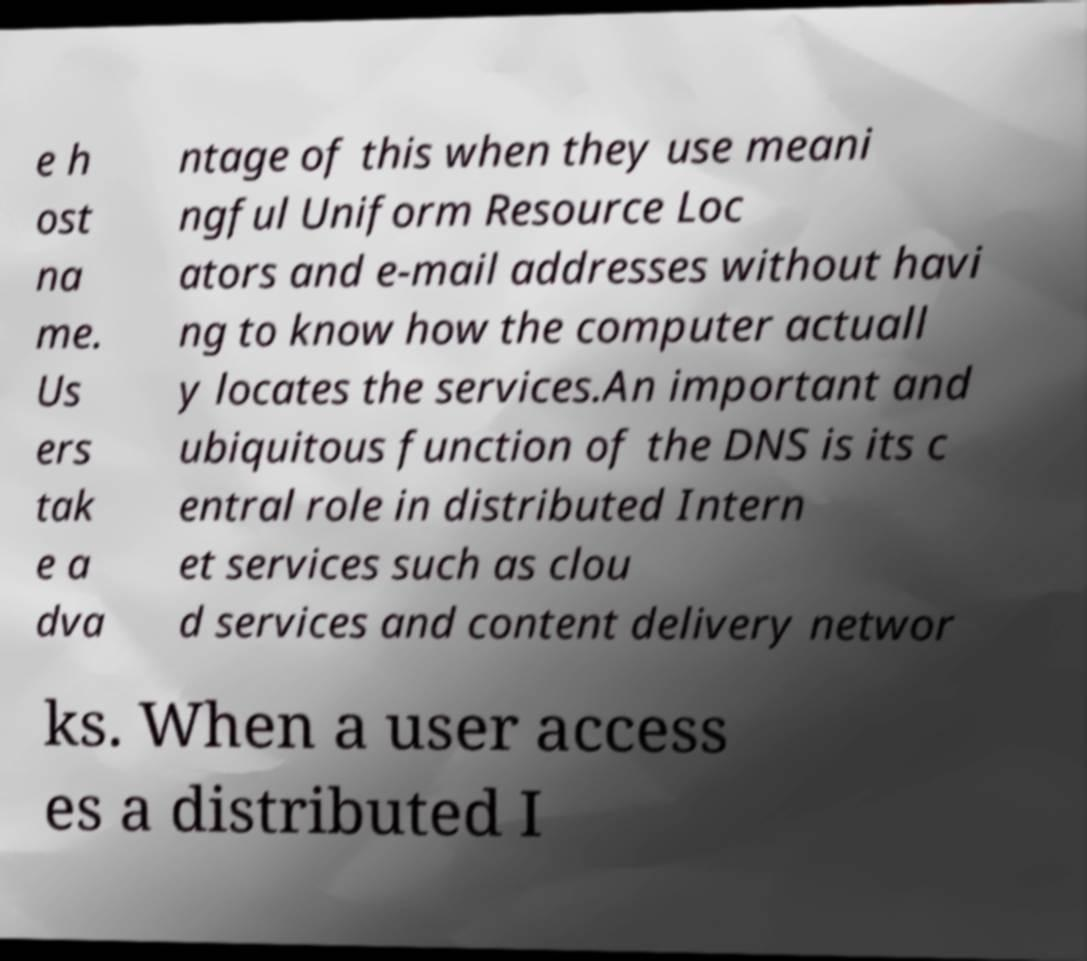Can you read and provide the text displayed in the image?This photo seems to have some interesting text. Can you extract and type it out for me? e h ost na me. Us ers tak e a dva ntage of this when they use meani ngful Uniform Resource Loc ators and e-mail addresses without havi ng to know how the computer actuall y locates the services.An important and ubiquitous function of the DNS is its c entral role in distributed Intern et services such as clou d services and content delivery networ ks. When a user access es a distributed I 